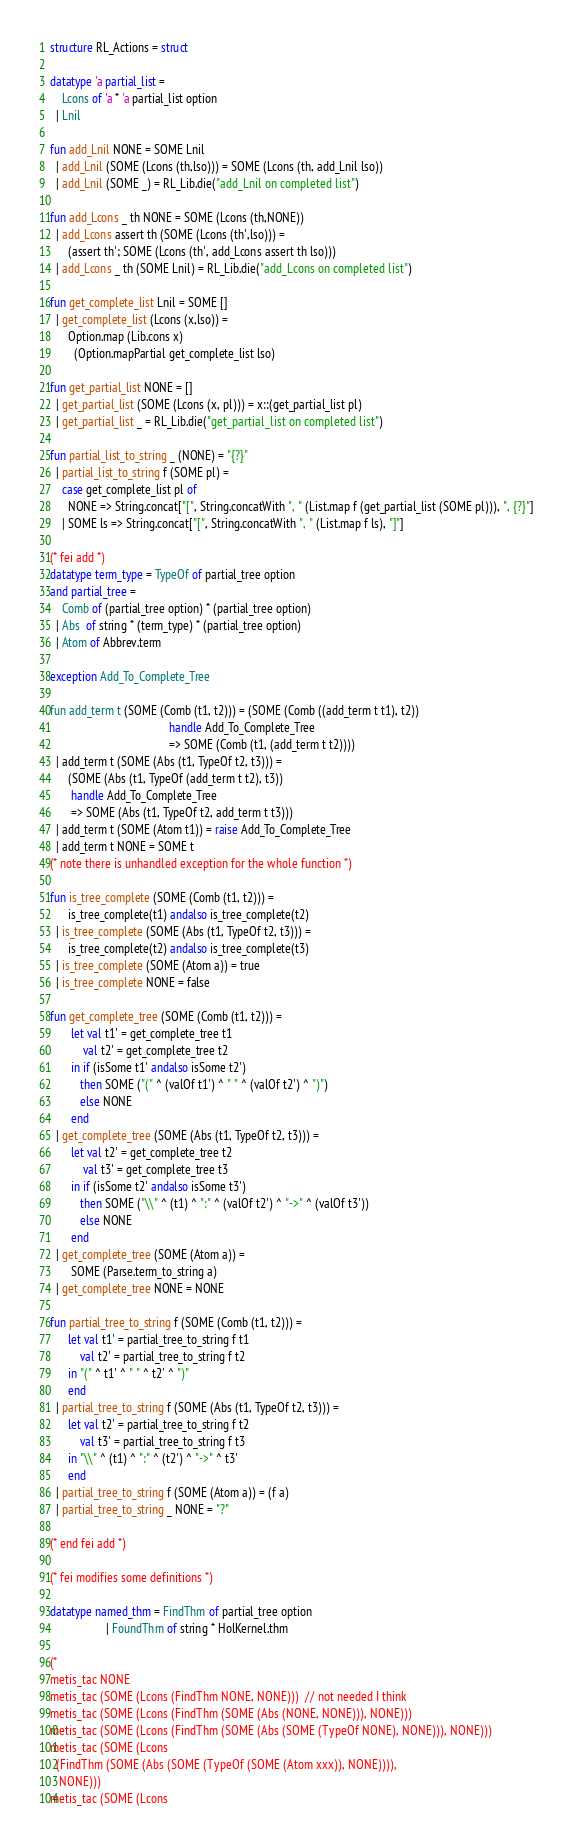<code> <loc_0><loc_0><loc_500><loc_500><_SML_>structure RL_Actions = struct

datatype 'a partial_list =
    Lcons of 'a * 'a partial_list option
  | Lnil

fun add_Lnil NONE = SOME Lnil
  | add_Lnil (SOME (Lcons (th,lso))) = SOME (Lcons (th, add_Lnil lso))
  | add_Lnil (SOME _) = RL_Lib.die("add_Lnil on completed list")

fun add_Lcons _ th NONE = SOME (Lcons (th,NONE))
  | add_Lcons assert th (SOME (Lcons (th',lso))) =
      (assert th'; SOME (Lcons (th', add_Lcons assert th lso)))
  | add_Lcons _ th (SOME Lnil) = RL_Lib.die("add_Lcons on completed list")

fun get_complete_list Lnil = SOME []
  | get_complete_list (Lcons (x,lso)) =
      Option.map (Lib.cons x)
        (Option.mapPartial get_complete_list lso)

fun get_partial_list NONE = []
  | get_partial_list (SOME (Lcons (x, pl))) = x::(get_partial_list pl)
  | get_partial_list _ = RL_Lib.die("get_partial_list on completed list")

fun partial_list_to_string _ (NONE) = "{?}"
  | partial_list_to_string f (SOME pl) =
    case get_complete_list pl of
      NONE => String.concat["[", String.concatWith ", " (List.map f (get_partial_list (SOME pl))), ", {?}"]
    | SOME ls => String.concat["[", String.concatWith ", " (List.map f ls), "]"]

(* fei add *)
datatype term_type = TypeOf of partial_tree option
and partial_tree =
    Comb of (partial_tree option) * (partial_tree option)
  | Abs  of string * (term_type) * (partial_tree option)
  | Atom of Abbrev.term

exception Add_To_Complete_Tree

fun add_term t (SOME (Comb (t1, t2))) = (SOME (Comb ((add_term t t1), t2))
                                        handle Add_To_Complete_Tree
                                        => SOME (Comb (t1, (add_term t t2))))
  | add_term t (SOME (Abs (t1, TypeOf t2, t3))) =
      (SOME (Abs (t1, TypeOf (add_term t t2), t3))
       handle Add_To_Complete_Tree
       => SOME (Abs (t1, TypeOf t2, add_term t t3)))
  | add_term t (SOME (Atom t1)) = raise Add_To_Complete_Tree
  | add_term t NONE = SOME t
(* note there is unhandled exception for the whole function *)

fun is_tree_complete (SOME (Comb (t1, t2))) =
      is_tree_complete(t1) andalso is_tree_complete(t2)
  | is_tree_complete (SOME (Abs (t1, TypeOf t2, t3))) =
      is_tree_complete(t2) andalso is_tree_complete(t3)
  | is_tree_complete (SOME (Atom a)) = true
  | is_tree_complete NONE = false

fun get_complete_tree (SOME (Comb (t1, t2))) =
       let val t1' = get_complete_tree t1
           val t2' = get_complete_tree t2
       in if (isSome t1' andalso isSome t2')
          then SOME ("(" ^ (valOf t1') ^ " " ^ (valOf t2') ^ ")")
          else NONE
       end
  | get_complete_tree (SOME (Abs (t1, TypeOf t2, t3))) =
       let val t2' = get_complete_tree t2
           val t3' = get_complete_tree t3
       in if (isSome t2' andalso isSome t3')
          then SOME ("\\" ^ (t1) ^ ":" ^ (valOf t2') ^ "->" ^ (valOf t3'))
          else NONE
       end
  | get_complete_tree (SOME (Atom a)) =
       SOME (Parse.term_to_string a)
  | get_complete_tree NONE = NONE

fun partial_tree_to_string f (SOME (Comb (t1, t2))) =
      let val t1' = partial_tree_to_string f t1
          val t2' = partial_tree_to_string f t2
      in "(" ^ t1' ^ " " ^ t2' ^ ")"
      end
  | partial_tree_to_string f (SOME (Abs (t1, TypeOf t2, t3))) =
      let val t2' = partial_tree_to_string f t2
          val t3' = partial_tree_to_string f t3
      in "\\" ^ (t1) ^ ":" ^ (t2') ^ "->" ^ t3'
      end
  | partial_tree_to_string f (SOME (Atom a)) = (f a)
  | partial_tree_to_string _ NONE = "?"

(* end fei add *)

(* fei modifies some definitions *)

datatype named_thm = FindThm of partial_tree option
                   | FoundThm of string * HolKernel.thm

(*
metis_tac NONE
metis_tac (SOME (Lcons (FindThm NONE, NONE)))  // not needed I think
metis_tac (SOME (Lcons (FindThm (SOME (Abs (NONE, NONE))), NONE)))
metis_tac (SOME (Lcons (FindThm (SOME (Abs (SOME (TypeOf NONE), NONE))), NONE)))
metis_tac (SOME (Lcons
  (FindThm (SOME (Abs (SOME (TypeOf (SOME (Atom xxx)), NONE)))),
   NONE)))
metis_tac (SOME (Lcons</code> 